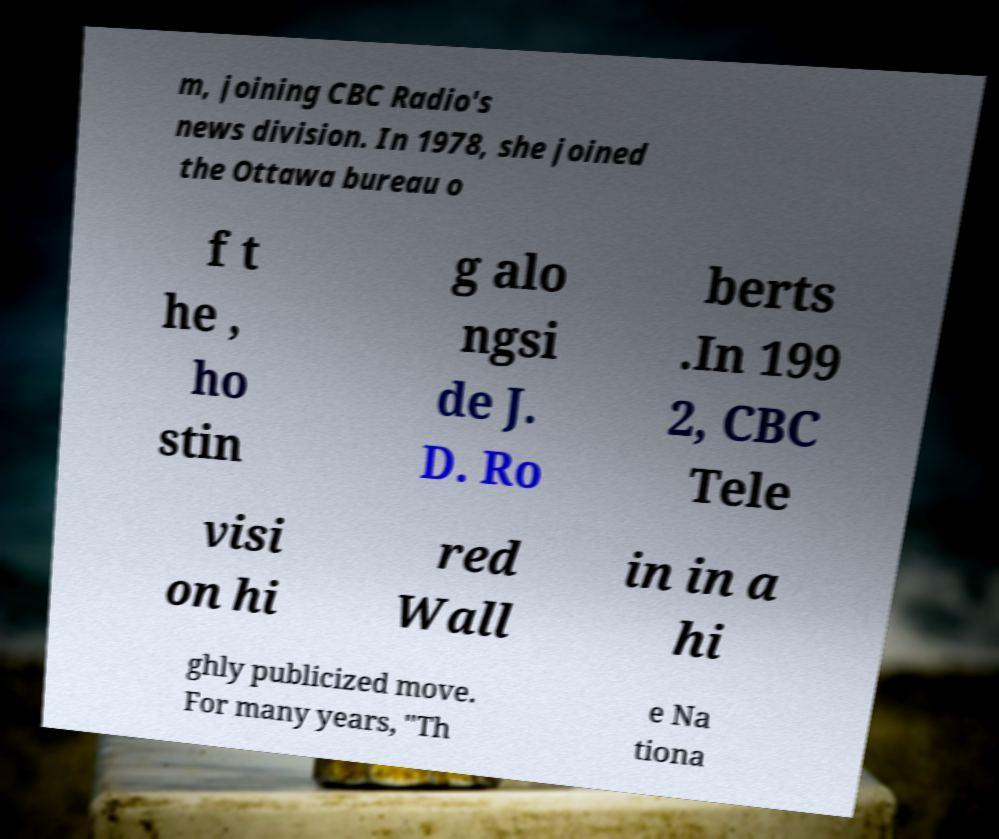I need the written content from this picture converted into text. Can you do that? m, joining CBC Radio's news division. In 1978, she joined the Ottawa bureau o f t he , ho stin g alo ngsi de J. D. Ro berts .In 199 2, CBC Tele visi on hi red Wall in in a hi ghly publicized move. For many years, "Th e Na tiona 